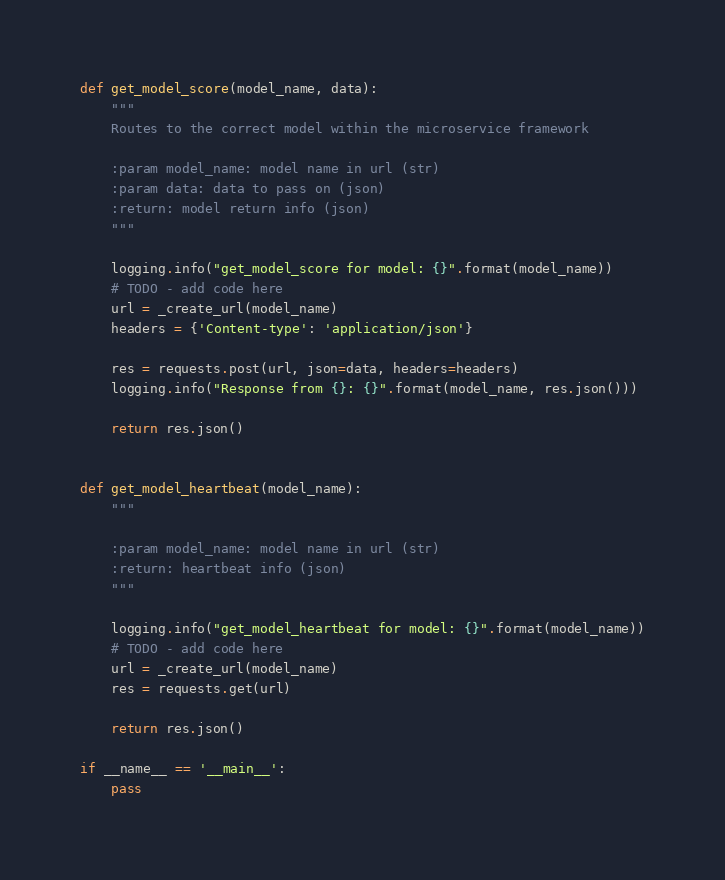Convert code to text. <code><loc_0><loc_0><loc_500><loc_500><_Python_>
def get_model_score(model_name, data):
    """
    Routes to the correct model within the microservice framework

    :param model_name: model name in url (str)
    :param data: data to pass on (json)
    :return: model return info (json)
    """

    logging.info("get_model_score for model: {}".format(model_name))
    # TODO - add code here
    url = _create_url(model_name)
    headers = {'Content-type': 'application/json'}

    res = requests.post(url, json=data, headers=headers)
    logging.info("Response from {}: {}".format(model_name, res.json()))

    return res.json()


def get_model_heartbeat(model_name):
    """

    :param model_name: model name in url (str)
    :return: heartbeat info (json)
    """

    logging.info("get_model_heartbeat for model: {}".format(model_name))
    # TODO - add code here
    url = _create_url(model_name)
    res = requests.get(url)

    return res.json()

if __name__ == '__main__':
    pass
</code> 